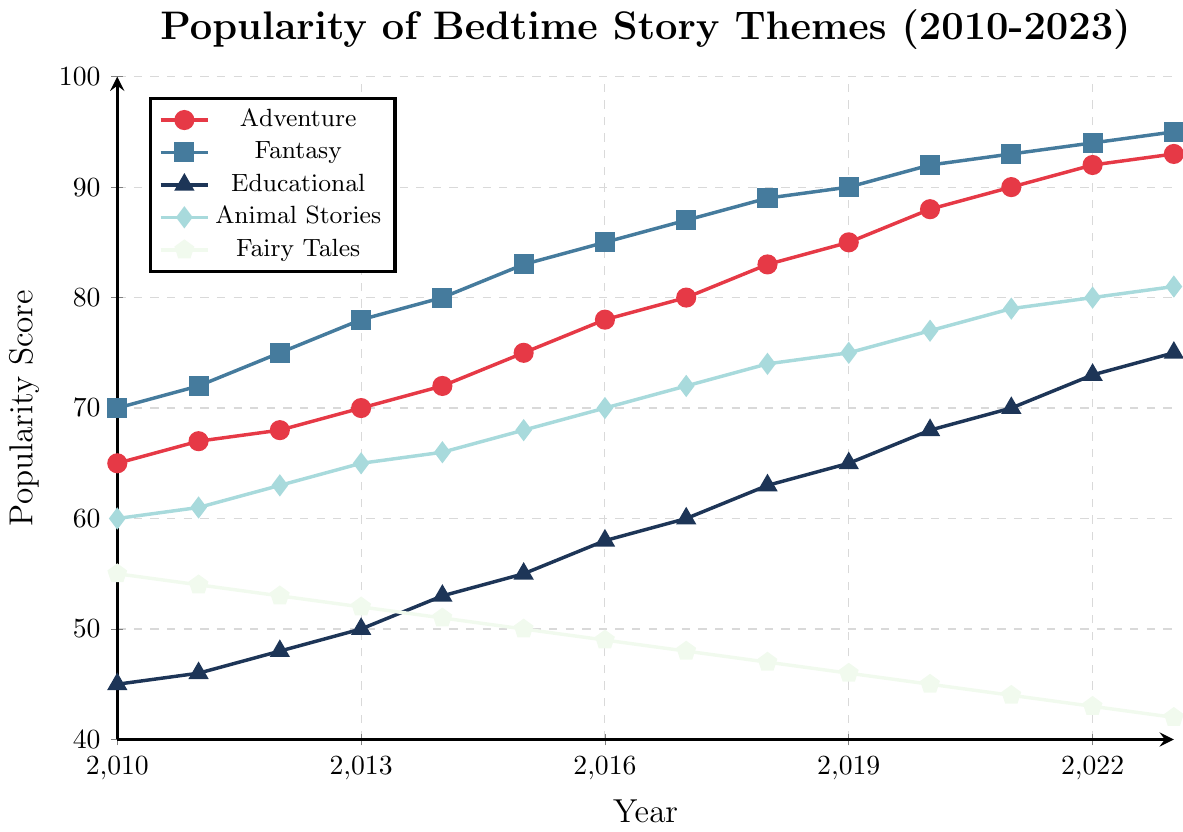Which theme had the highest popularity in 2010? In 2010, the Fantasy theme had the highest popularity score of 70, according to the plot.
Answer: Fantasy Which theme decreased in popularity over the years? The Fairy Tales theme consistently dropped from 55 in 2010 to 42 in 2023, showing a steady decline.
Answer: Fairy Tales How much did the popularity of Educational stories increase from 2010 to 2023? In 2010, the popularity of Educational stories was 45, and by 2023 it was 75. The increase is calculated as 75 - 45 = 30.
Answer: 30 Between which years did Animal Stories see the highest increase in popularity? From 2019 to 2020, Animal Stories' popularity increased from 75 to 77, which is a significant jump compared to other years.
Answer: 2019 to 2020 Comparing Adventure and Educational themes, which saw greater growth from 2010 to 2023? Adventure grew from 65 to 93, an increase of 28. Educational grew from 45 to 75, an increase of 30. Hence, Educational saw a greater growth.
Answer: Educational What is the average popularity score for Fantasy stories over these years? The Fantasy theme's scores are 70, 72, 75, 78, 80, 83, 85, 87, 89, 90, 92, 93, 94, 95. The sum of these scores is 1193, and the average is 1193/14 = 85.21.
Answer: 85.21 Which themes had a popularity score of 81 in 2023? According to the plot, only Animal Stories had a popularity score of 81 in 2023.
Answer: Animal Stories In which year did the Adventure theme surpass 90 in popularity? The Adventure theme surpassed a popularity score of 90 in the year 2021.
Answer: 2021 What is the difference in popularity between Fantasy and Fairy Tales in 2023? The popularity for Fantasy in 2023 is 95 and for Fairy Tales is 42. The difference is 95 - 42 = 53.
Answer: 53 During which years did the Adventure theme have a greater increase than the Fantasy theme? From 2010 to 2011 (2 vs 2) and from 2015 to 2016 (3 vs 2), but the Adventure theme mostly had less or equal increases compared to Fantasy.
Answer: Two specific years: 2013-2014 and 2015-2016 